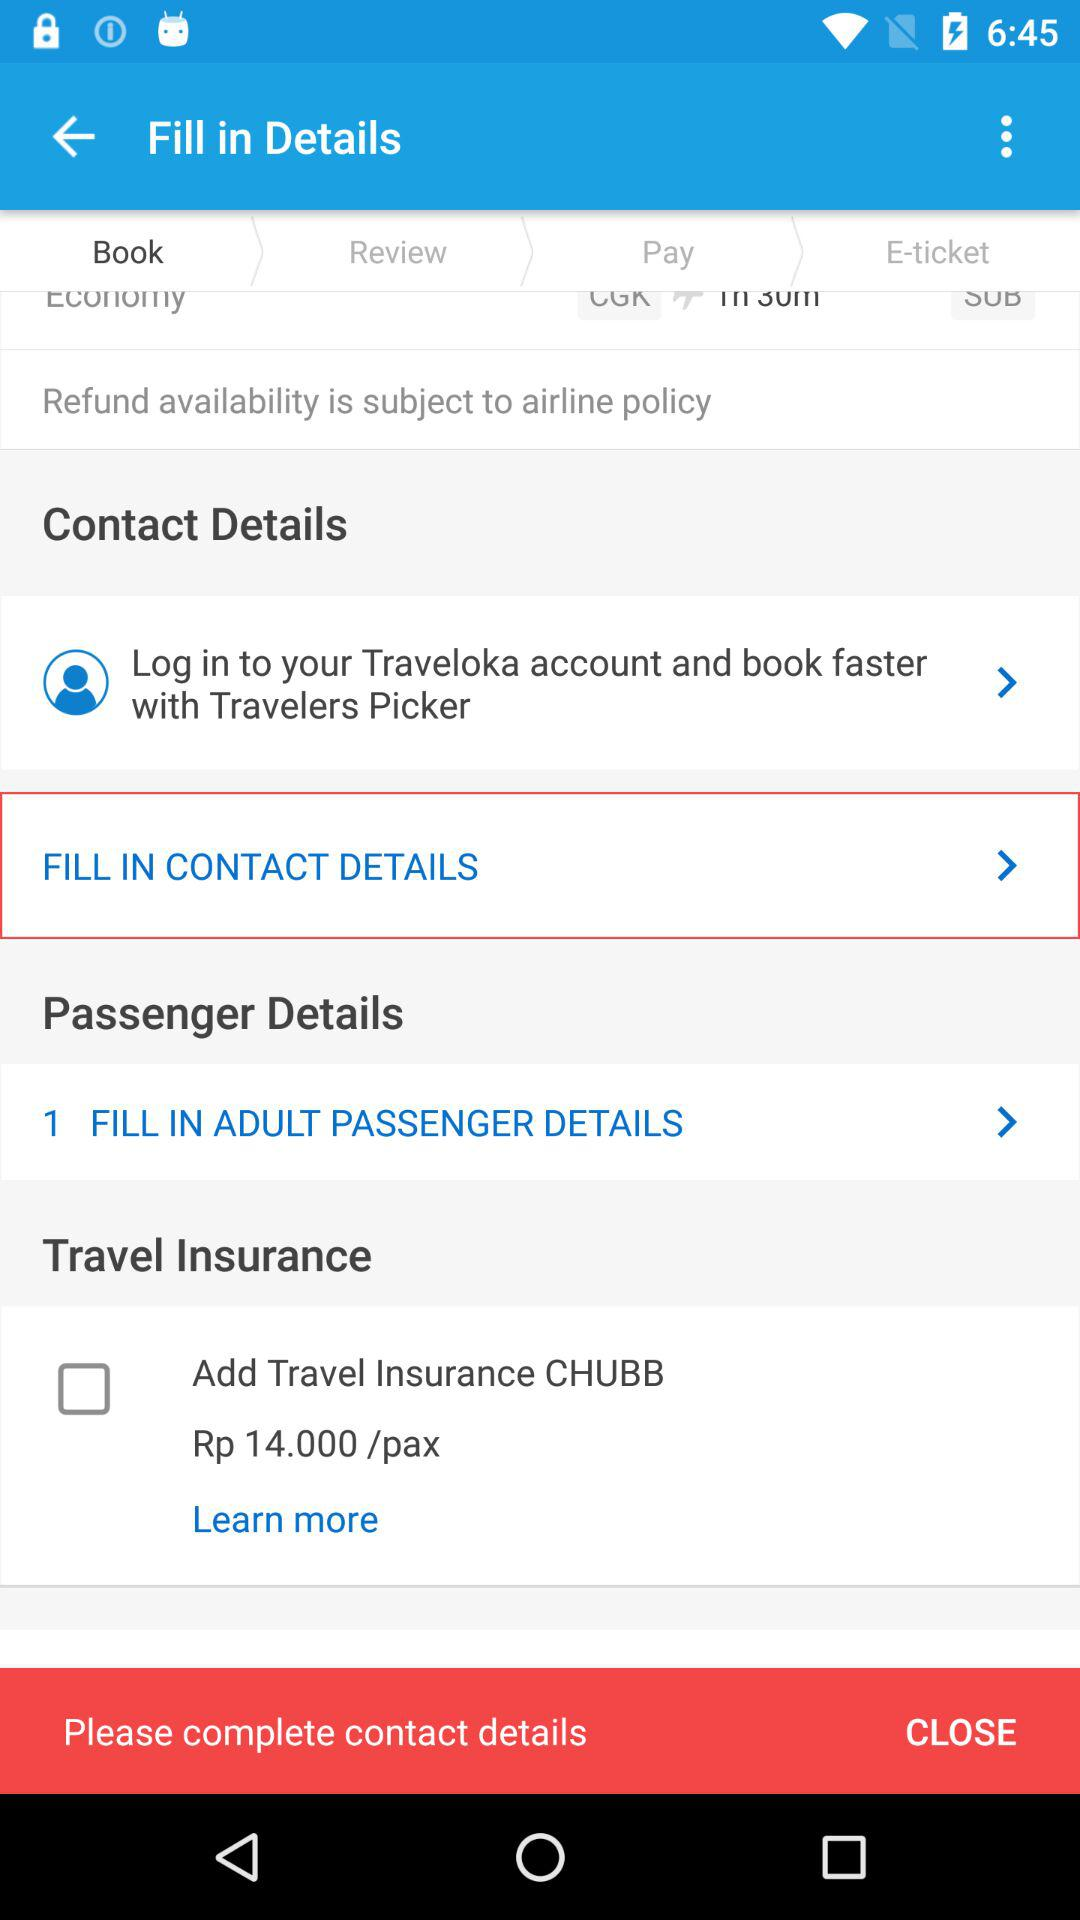What is the price per pax? The price is Rp 14/pax. 